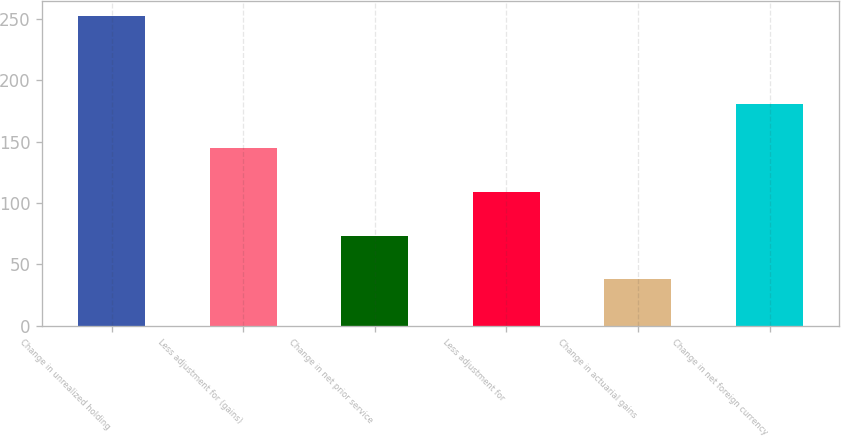Convert chart. <chart><loc_0><loc_0><loc_500><loc_500><bar_chart><fcel>Change in unrealized holding<fcel>Less adjustment for (gains)<fcel>Change in net prior service<fcel>Less adjustment for<fcel>Change in actuarial gains<fcel>Change in net foreign currency<nl><fcel>251.9<fcel>144.8<fcel>73.4<fcel>109.1<fcel>37.7<fcel>180.5<nl></chart> 